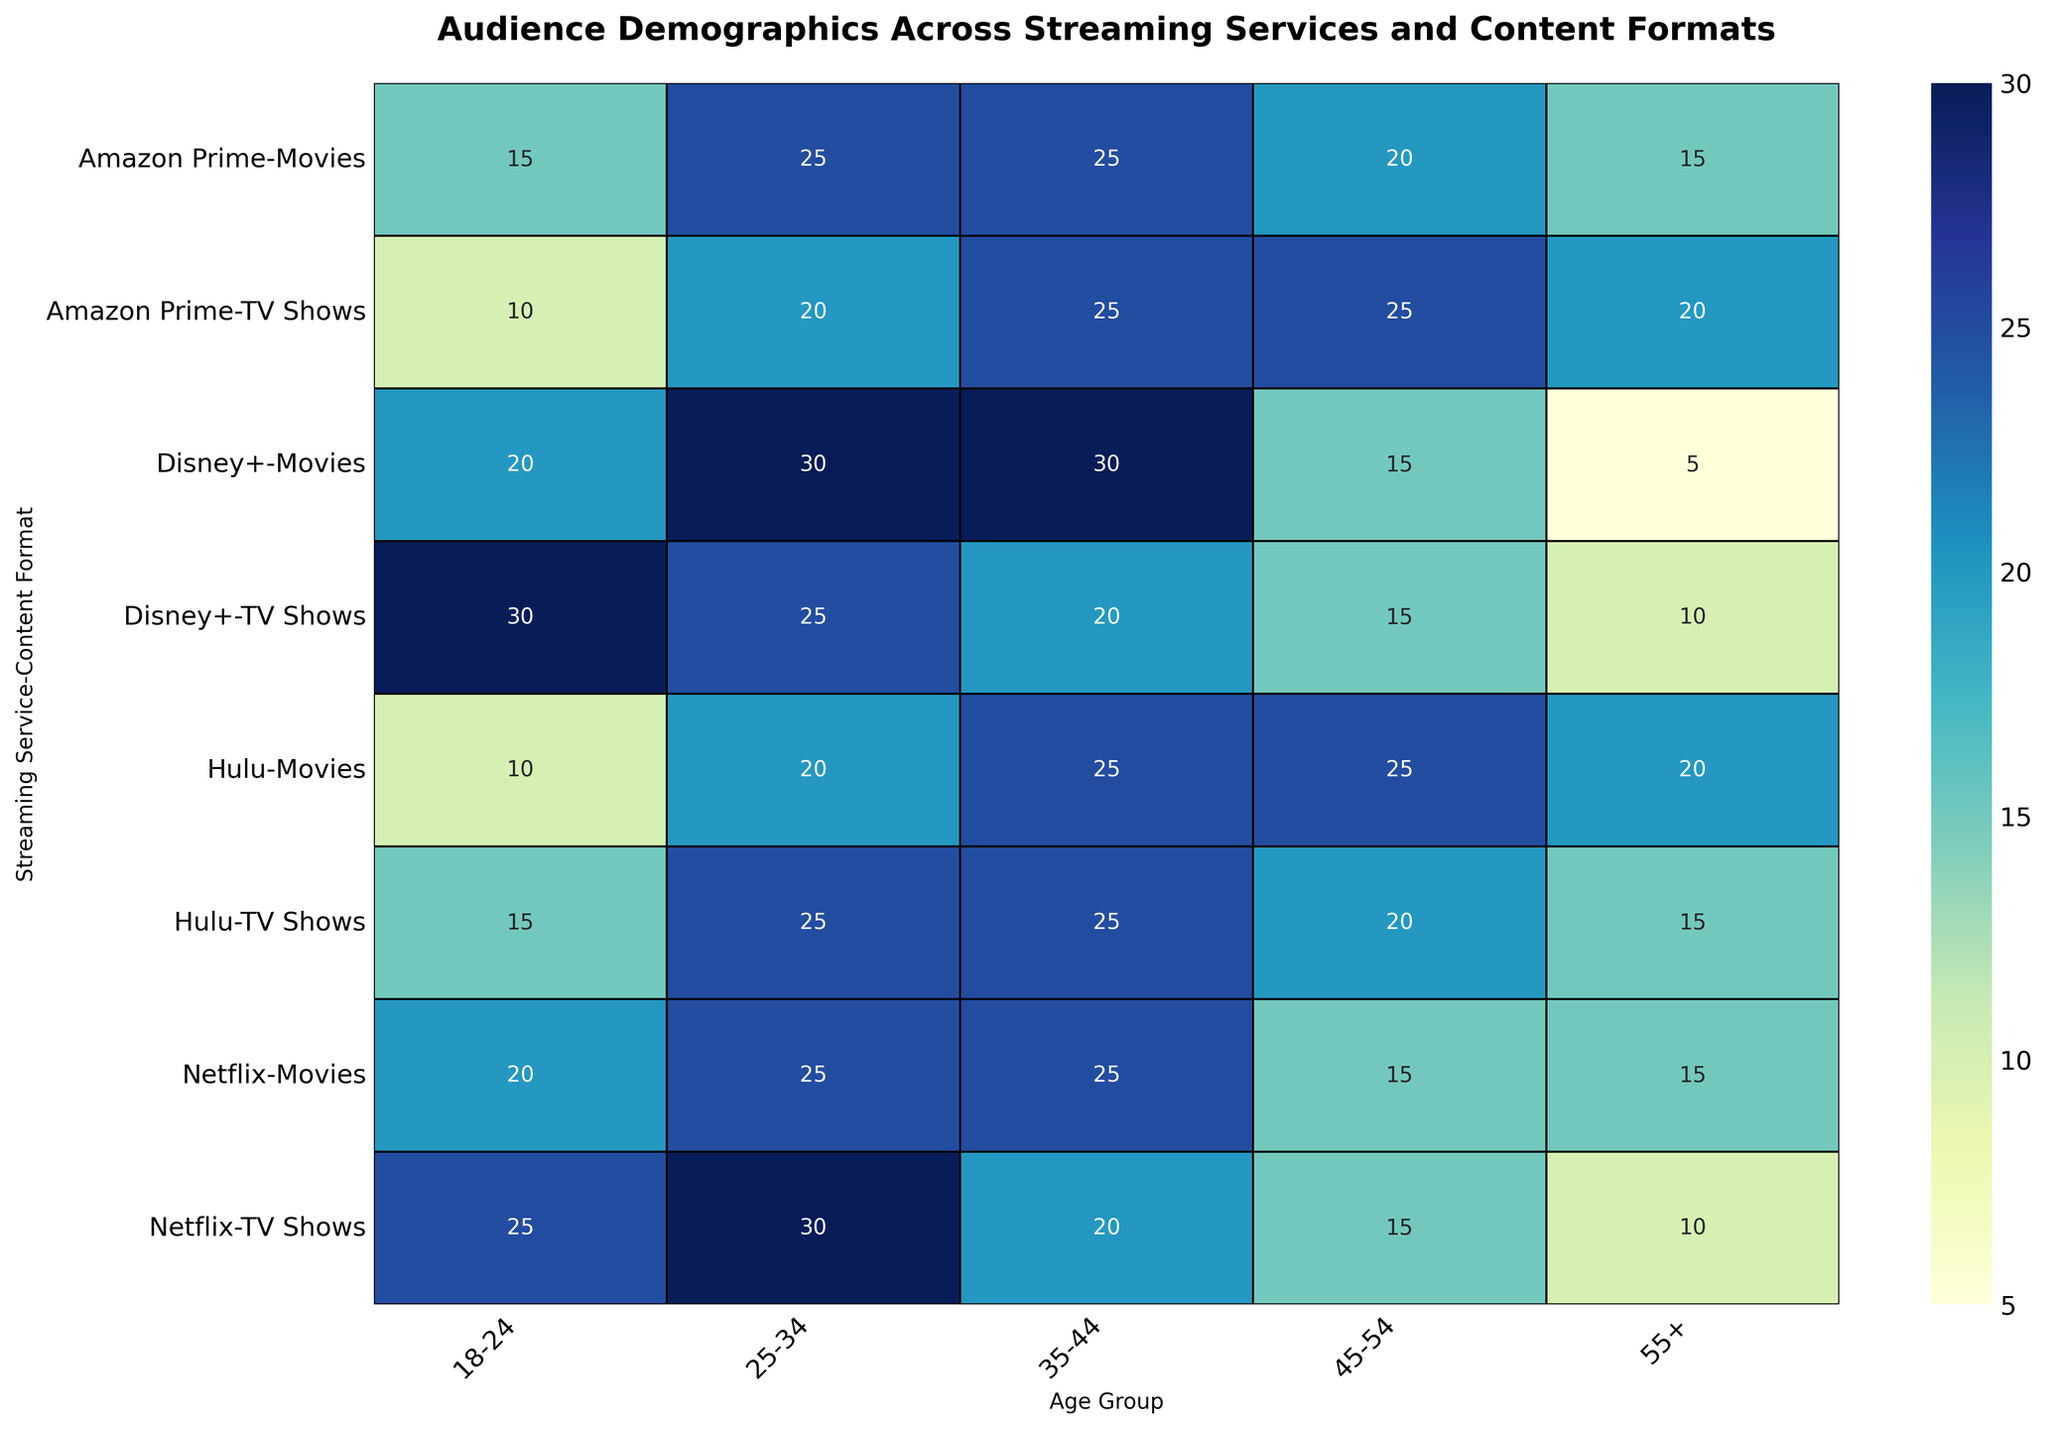Which age group has the highest viewership for Disney+ TV shows? By looking at the heatmap, identify the age group with the highest percentage value under Disney+ for TV shows. The highest value should be the darkest or most intense color.
Answer: 18-24 Compare the percentage of viewers aged 45-54 for Netflix TV shows and Hulu TV shows. Which is higher? Find the cell for viewers aged 45-54 under Netflix TV shows and Hulu TV shows, and compare the percentage values. For Netflix, the value is 15, and for Hulu, it is 20.
Answer: Hulu What is the difference in the percentage of 25-34-year-olds watching movies on Netflix versus Disney+? Locate the percentage values for the 25-34 age group watching movies on Netflix and Disney+ within the heatmap. For Netflix, the value is 25, and for Disney+, it is 30. The difference is 30 - 25.
Answer: 5 Are there more viewers aged 55+ watching TV shows on Amazon Prime or Hulu? Examine the heatmap cells corresponding to the 55+ age group for TV shows on Amazon Prime and Hulu. For Amazon Prime, the value is 20, and for Hulu, the value is 15.
Answer: Amazon Prime What's the combined percentage of 18-24-year-olds watching movies across all the streaming services? Sum the percentage values for the 18-24 age group watching movies across Netflix, Hulu, Amazon Prime, and Disney+. The values are 20, 10, 15, and 20 respectively. 20 + 10 + 15 + 20 = 65.
Answer: 65 How does the percentage of 35-44-year-olds watching TV shows on Amazon Prime compare to Disney+? Locate the percentage values for the 35-44 age group for TV shows on Amazon Prime and Disney+. For Amazon Prime, the value is 25, and for Disney+, it is 20. Amazon Prime has the higher percentage.
Answer: Amazon Prime Which age group has the least variation in viewership percentages across all streaming services and content formats? Analyze the rows corresponding to each age group across both content formats and all streaming services. Calculate the range (max-min) within each row. The age group with the smallest range has the least variation. The results should show that the 45-54 age group has consistently close values.
Answer: 45-54 What is the average percentage of Hulu viewers aged 35-44 across both content formats? Find the percentage values for the 35-44 age group under TV shows and movies on Hulu. For TV shows, it is 25, and for movies, it is also 25. The average is (25 + 25) / 2 = 25.
Answer: 25 Is the percentage of 18-24-year-olds watching TV shows higher on Netflix or Disney+? Compare the values for the 18-24 age group watching TV shows on Netflix and Disney+. For Netflix, the value is 25, and for Disney+, it is 30. Disney+ has the higher percentage.
Answer: Disney+ The plot shows percentage data for different streaming services and content formats. What's the highest recorded percentage in the entire heatmap? Scan through the entire heatmap to identify the cell with the highest percentage value, which corresponds to the deepest or most intense color on the figure. The highest recorded value is for 18-24-year-olds watching TV shows on Disney+, 30.
Answer: 30 